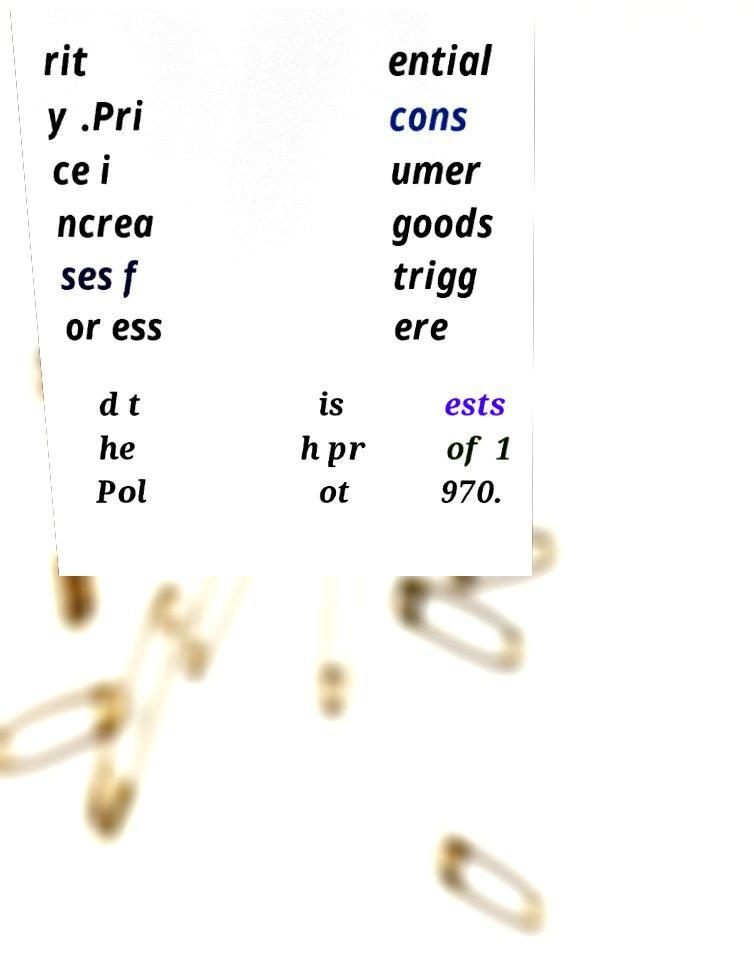Can you read and provide the text displayed in the image?This photo seems to have some interesting text. Can you extract and type it out for me? rit y .Pri ce i ncrea ses f or ess ential cons umer goods trigg ere d t he Pol is h pr ot ests of 1 970. 